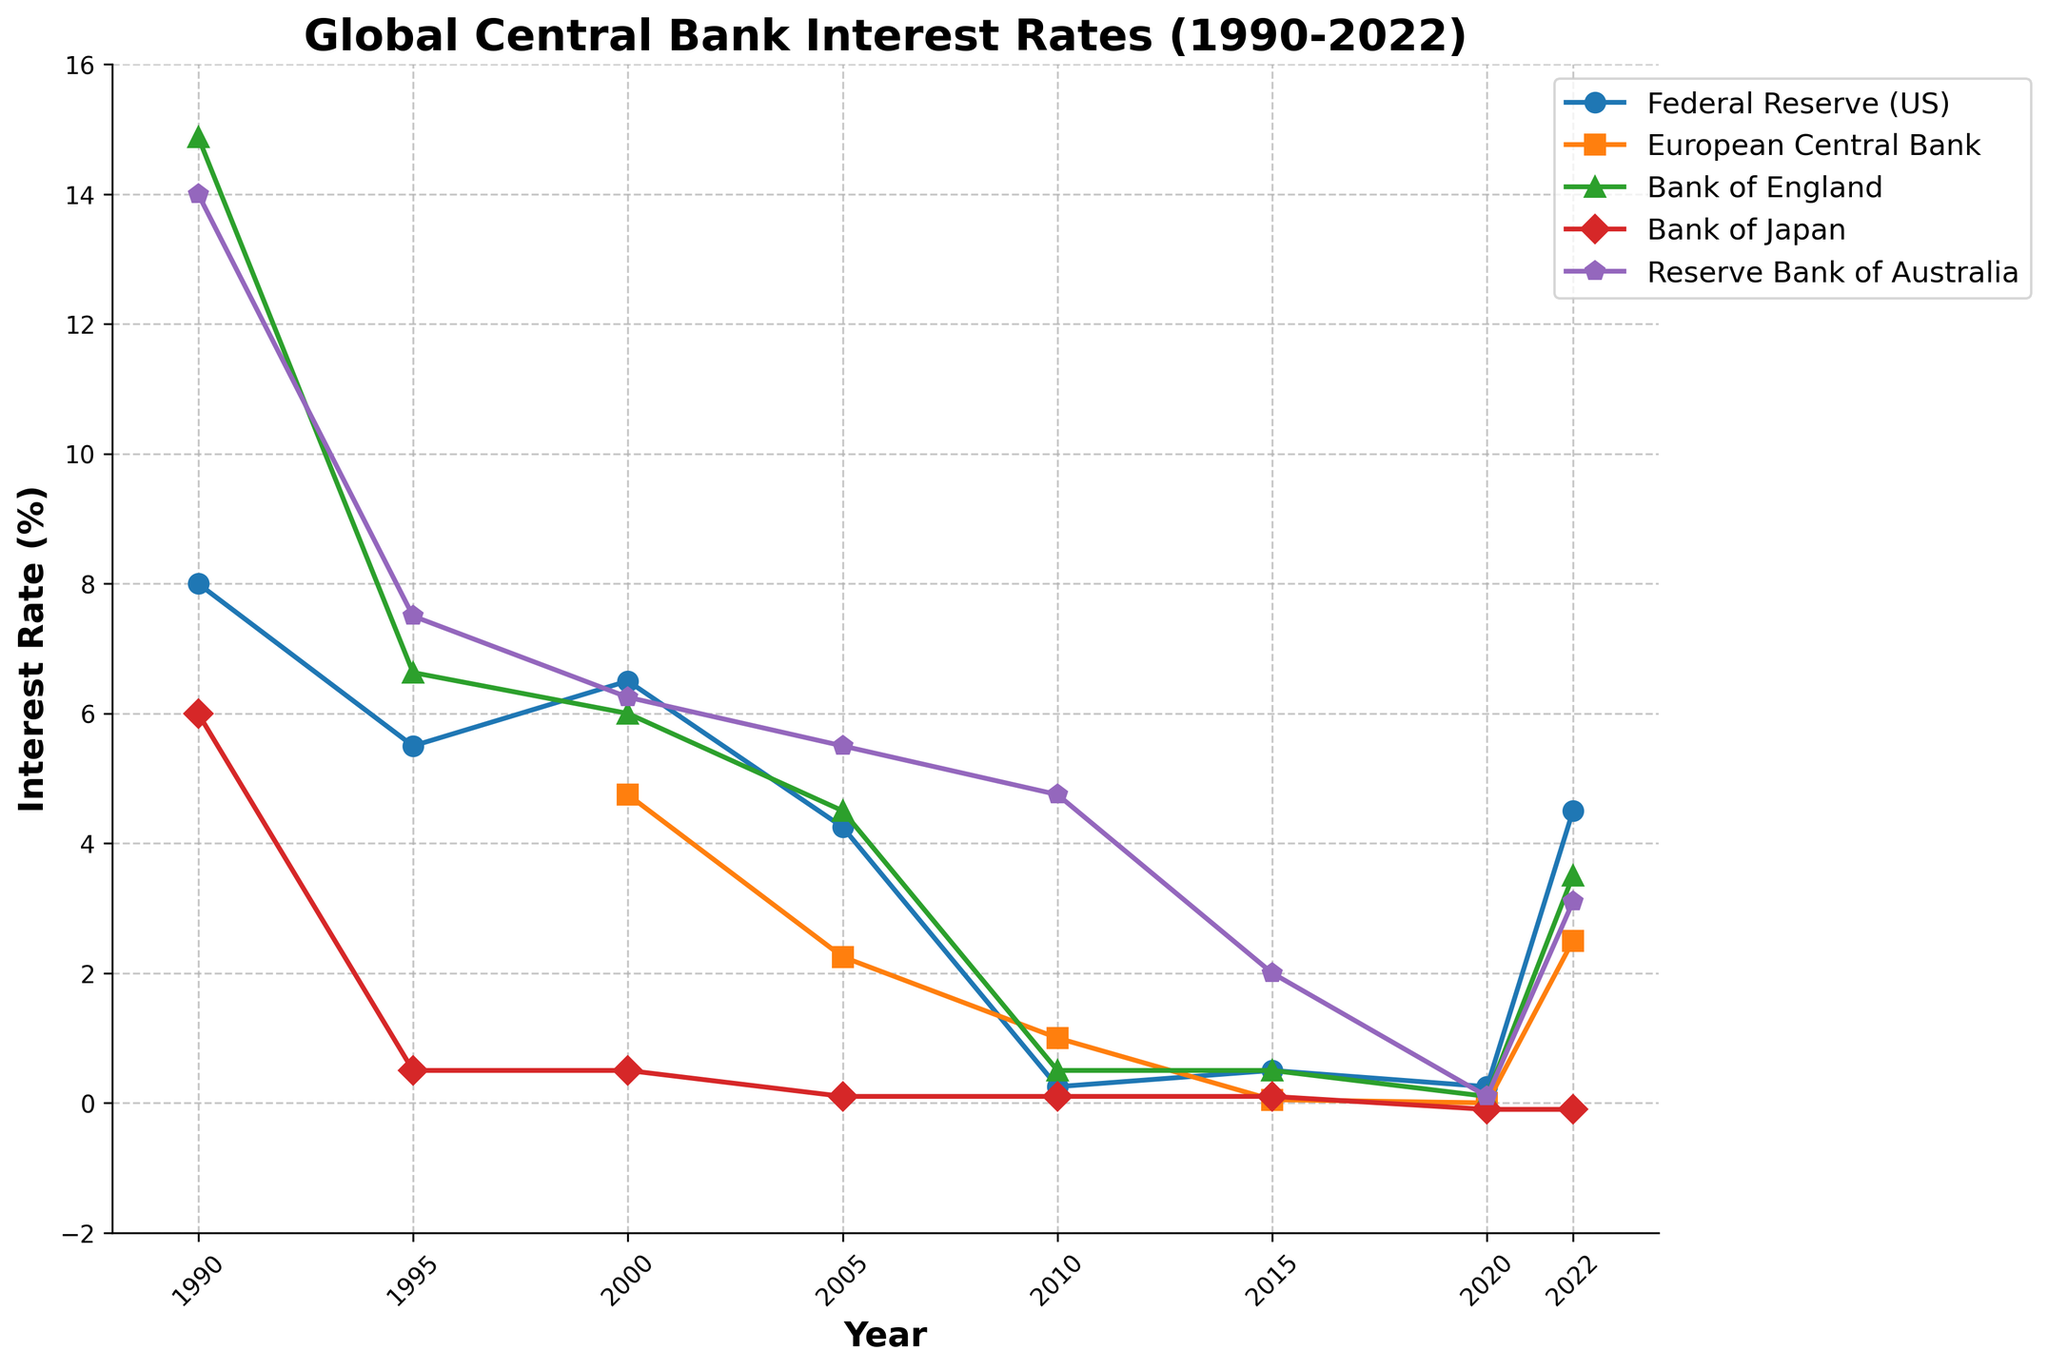Which central bank had the highest interest rate in 1990? By examining the data points in the figure for the year 1990, the Federal Reserve (US) has an interest rate of 8.00%, the European Central Bank data is not available, the Bank of England has 14.88%, the Bank of Japan has 6.00%, and the Reserve Bank of Australia has 14.00%. The highest interest rate is from the Bank of England at 14.88%.
Answer: Bank of England Compare the interest rate trends of the Federal Reserve (US) and the Reserve Bank of Australia between 1990 and 2022. Which one generally decreased more? From the visual observation of the lines, the Federal Reserve (US) started at 8.00% in 1990 and decreased to 4.50% in 2022. The Reserve Bank of Australia started at 14.00% in 1990 and decreased to 3.10% in 2022. The Reserve Bank of Australia had a more significant decrease of 10.90 percentage points compared to the Federal Reserve (US) which decreased by 3.50 percentage points.
Answer: Reserve Bank of Australia Between 2000 and 2020, which central bank maintained a consistent interest rate closest to zero? Based on the graph, the Bank of Japan maintained a very conservative interest rate closest to zero, with values such as 0.10% in 2005, 0.10% in 2010, 0.10% in 2015, and -0.10% in 2020. This shows consistency around zero compared to other central banks.
Answer: Bank of Japan Calculate the average interest rate of the European Central Bank from 2000 to 2022. The data points available in the figure for the European Central Bank are 4.75% (2000), 2.25% (2005), 1.00% (2010), 0.05% (2015), 0.00% (2020), and 2.50% (2022). Summing these values (4.75 + 2.25 + 1.00 + 0.05 + 0.00 + 2.50) gives 10.55 and dividing by 6 yields an average of ~1.76%.
Answer: ~1.76% Which two central banks had the closest interest rate in 2015, and what was that rate? Looking at the figure for the year 2015, the Federal Reserve (US) had an interest rate of 0.50%, the European Central Bank had 0.05%, the Bank of England also had 0.50%, the Bank of Japan had 0.10%, and the Reserve Bank of Australia had 2.00%. The Federal Reserve (US) and the Bank of England both had an interest rate of 0.50%, making their rates the closest.
Answer: Federal Reserve (US) and Bank of England, 0.50% Identify the general trend for the European Central Bank's interest rate from 2000 to 2022. Observing the line representing the European Central Bank, the trend shows a steady decline from 4.75% in 2000 to 2.25% in 2005, then to 1.00% in 2010. It further drops to 0.05% in 2015, reaches 0.00% in 2020, and slightly recovers to 2.50% in 2022. The general trend is a decrease with a minor increase towards the end.
Answer: Decrease with a minor increase towards the end Which central bank showed a negative interest rate in any year and which year was it? The overview of the visual data shows that the Bank of Japan had a negative interest rate of -0.10% in 2020 and maintained it in 2022.
Answer: Bank of Japan, 2020 and 2022 What is the difference in interest rate between the Bank of England and the Reserve Bank of Australia in 2005? According to the figure, the interest rate for the Bank of England in 2005 was 4.50% and for the Reserve Bank of Australia, it was 5.50%. Subtracting these values gives a difference of 1.00%.
Answer: 1.00% 